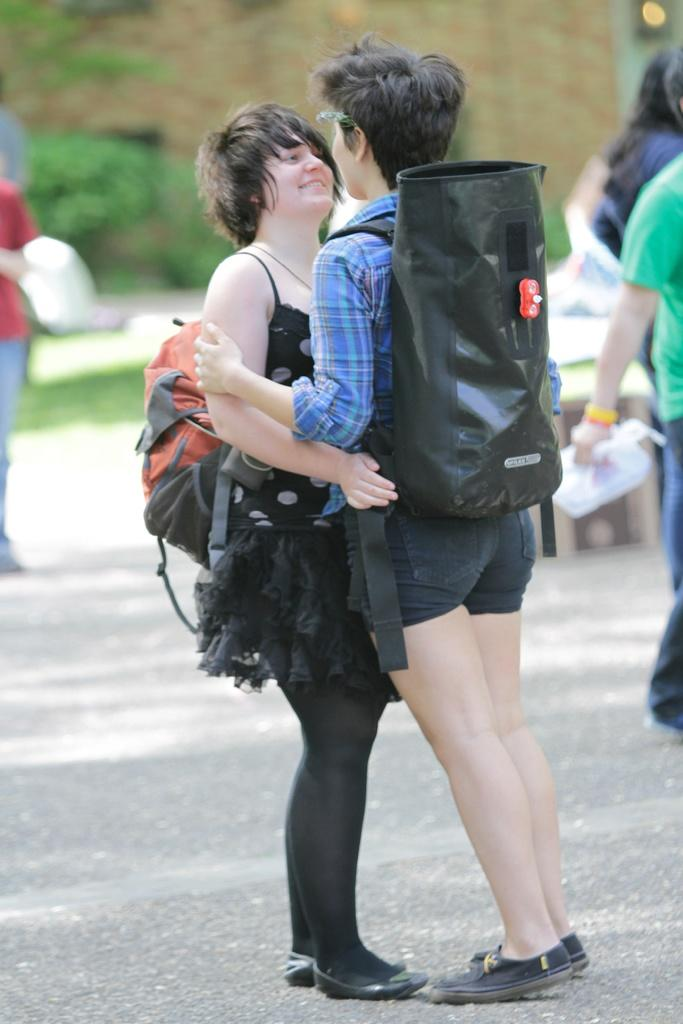How many people are in the foreground of the image? There are two persons standing in the middle of the image. What are the two persons in the foreground wearing? Both persons are wearing backpacks. Can you describe the background of the image? There are other persons and trees in the background of the image. What type of balls are being used by the spies in the image? There are no spies or balls present in the image. 